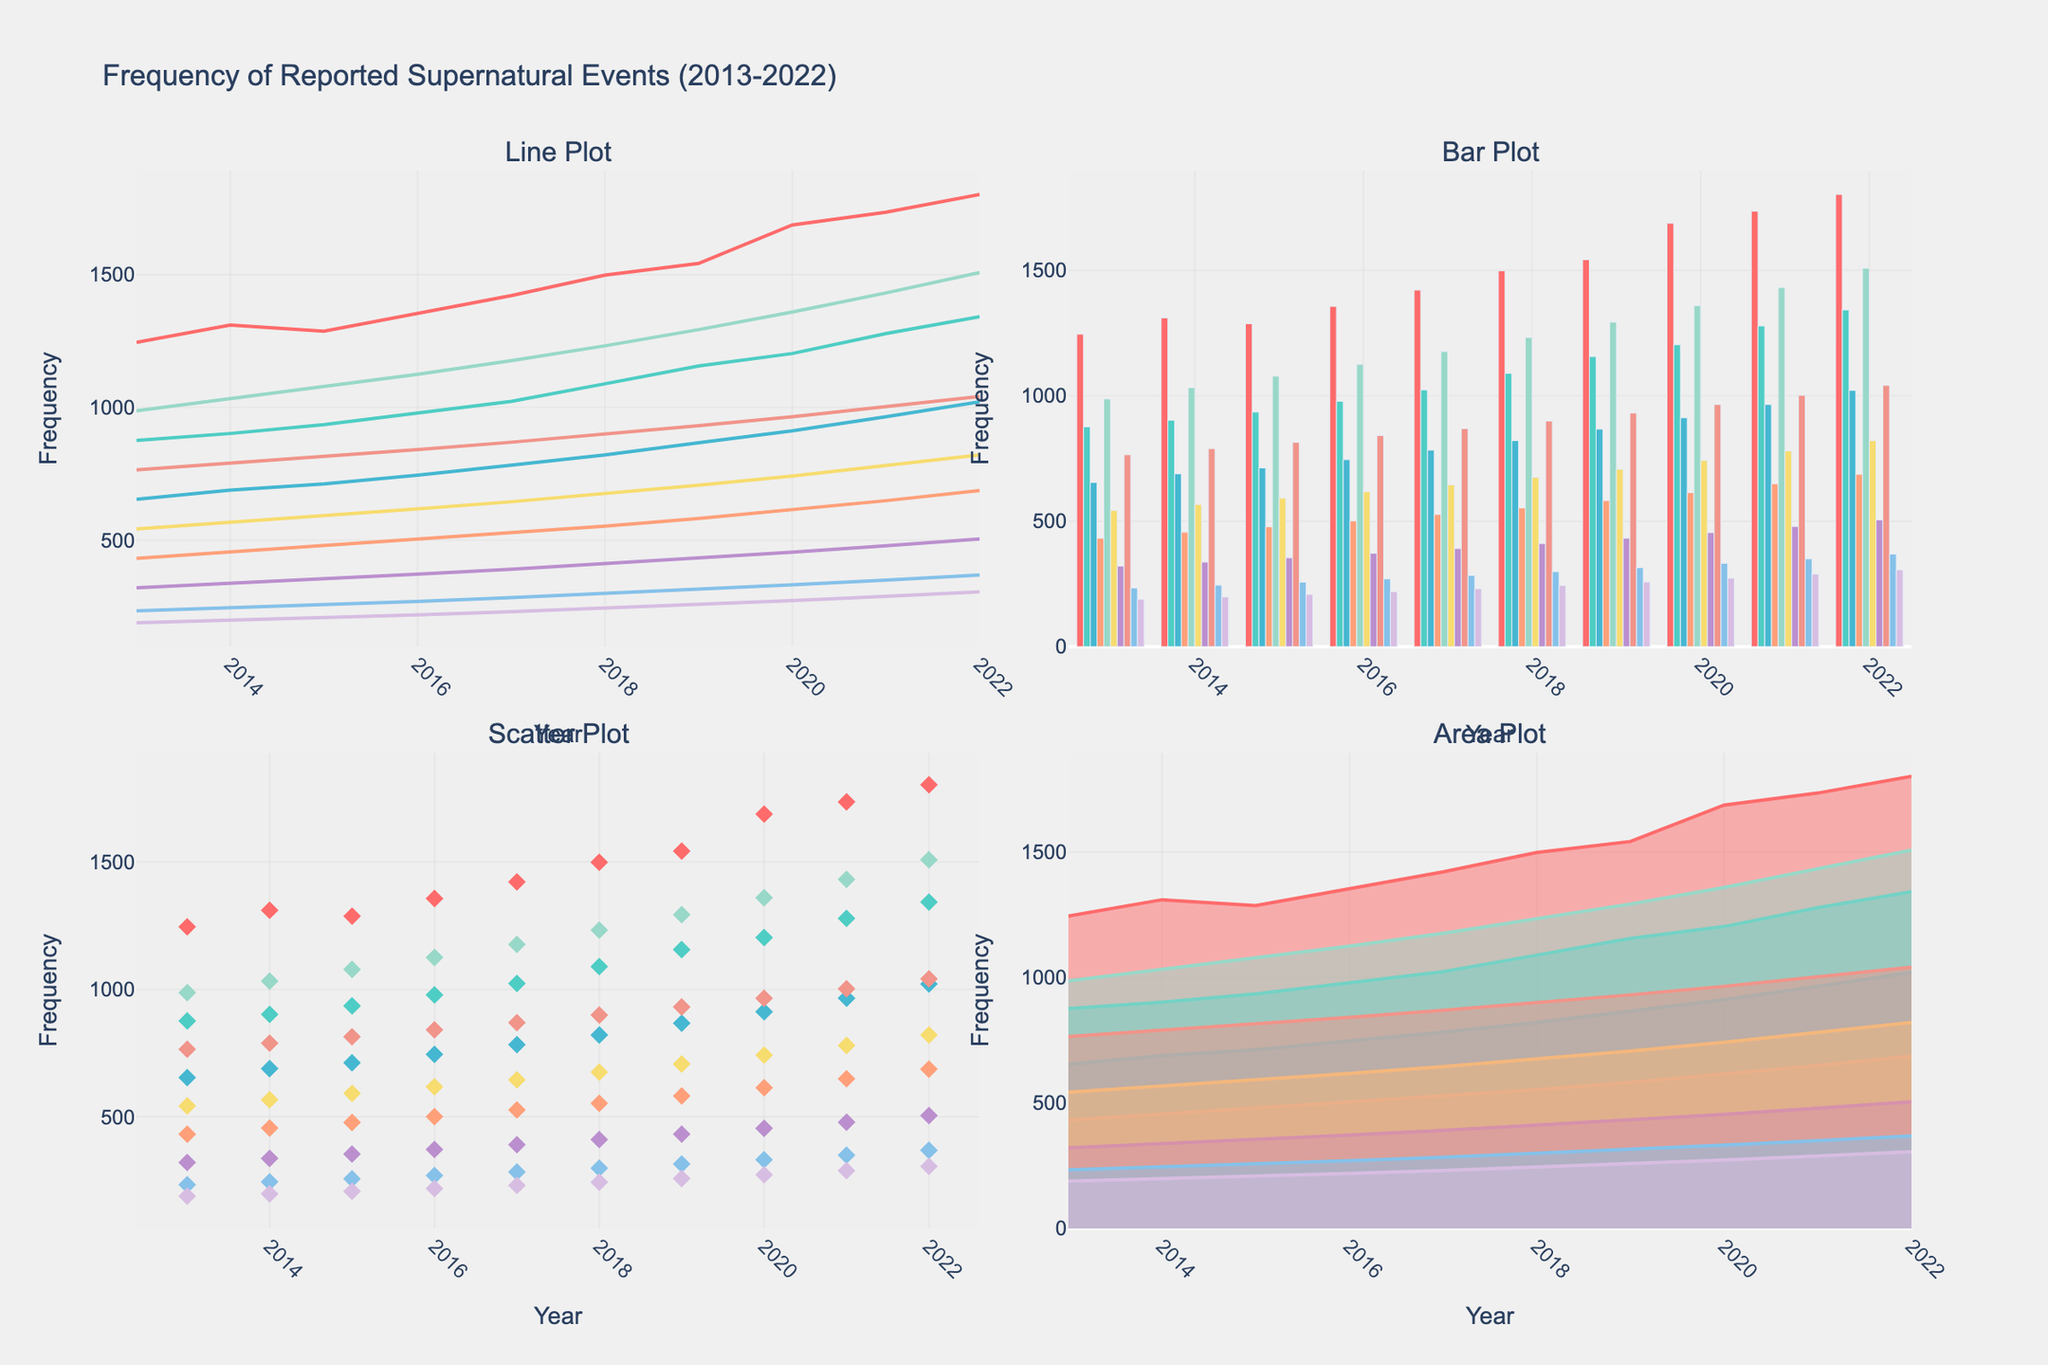What is the title of the figure? The title of the figure is located at the top of the chart and helps contextualize the data being visualized.
Answer: Frequency of Reported Supernatural Events (2013-2022) What are the labels for the x and y axes in any subplot? The labels for the axes are used to describe what each axis represents. The x-axis typically represents the year, and the y-axis represents the frequency of reported supernatural events.
Answer: Year and Frequency Which country shows the highest frequency of reported supernatural events in 2022 in any subplot? By examining the maximum y-value for the year 2022 across all subplots, the country with the highest value can be identified.
Answer: United States Which subplot shows an increasing trend more evidently? Trends can be more easily identified in line plots as the continuous connection between points visualizes the progression over time.
Answer: Line Plot Compare the frequency of events in the United States and Japan in 2017 using any subplot. Look for the data points corresponding to the year 2017 for both the United States and Japan, and compare their y-values.
Answer: United States: 1421, Japan: 1023 Which subplot can be used to better compare the frequencies for each year across multiple countries, and why? Subplots like bar plots allow for clearer year-over-year comparison because each bar represents a different country within the same year, making it easier to compare heights visually.
Answer: Bar Plot What is the average frequency of reported supernatural events in Egypt from 2018 to 2022? To find the average, sum the data points from 2018 to 2022 for Egypt and divide by the number of points. (299 + 315 + 332 + 350 + 369) = 1665, then 1665/5 = 333
Answer: 333 Which subplot would best show the overall contribution of each country’s frequency over the decade and why? Area plots show the cumulative contribution over time as the shaded areas represent the accumulated values, making it easier to see overall contributions.
Answer: Area Plot By how much did the frequency of reported supernatural events in Ireland increase from 2013 to 2022 using any subplot? Subtract the value in 2013 from the value in 2022 for Ireland. (306 - 189) = 117
Answer: 117 